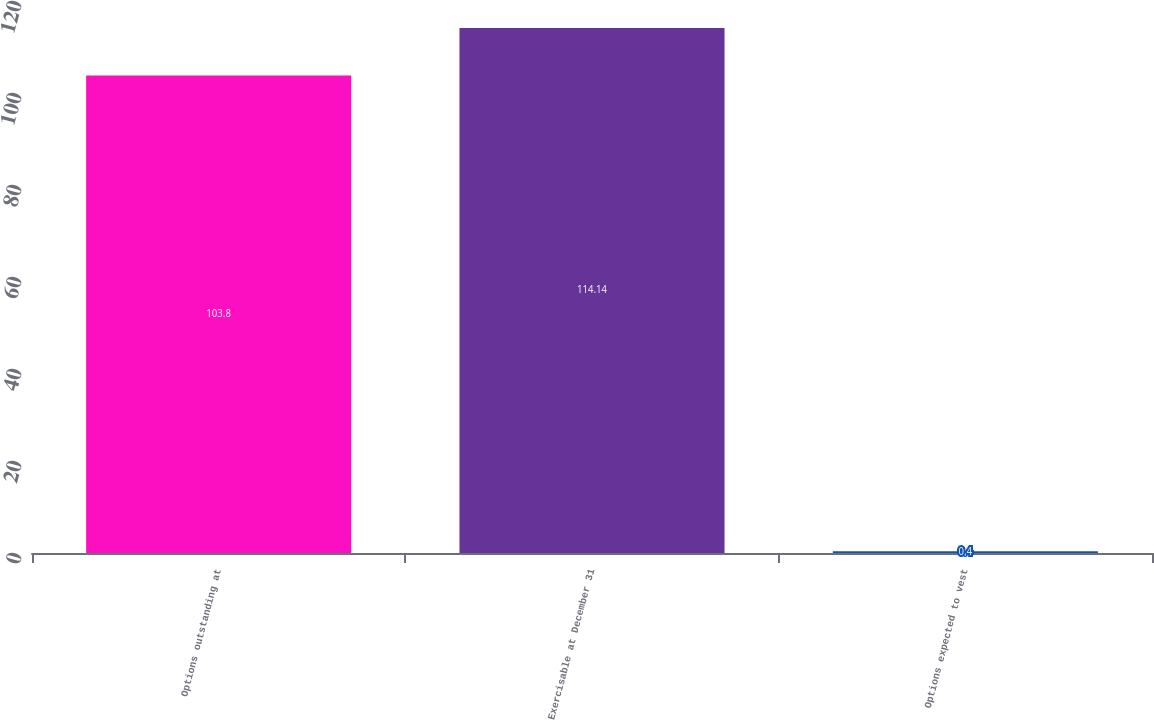Convert chart to OTSL. <chart><loc_0><loc_0><loc_500><loc_500><bar_chart><fcel>Options outstanding at<fcel>Exercisable at December 31<fcel>Options expected to vest<nl><fcel>103.8<fcel>114.14<fcel>0.4<nl></chart> 